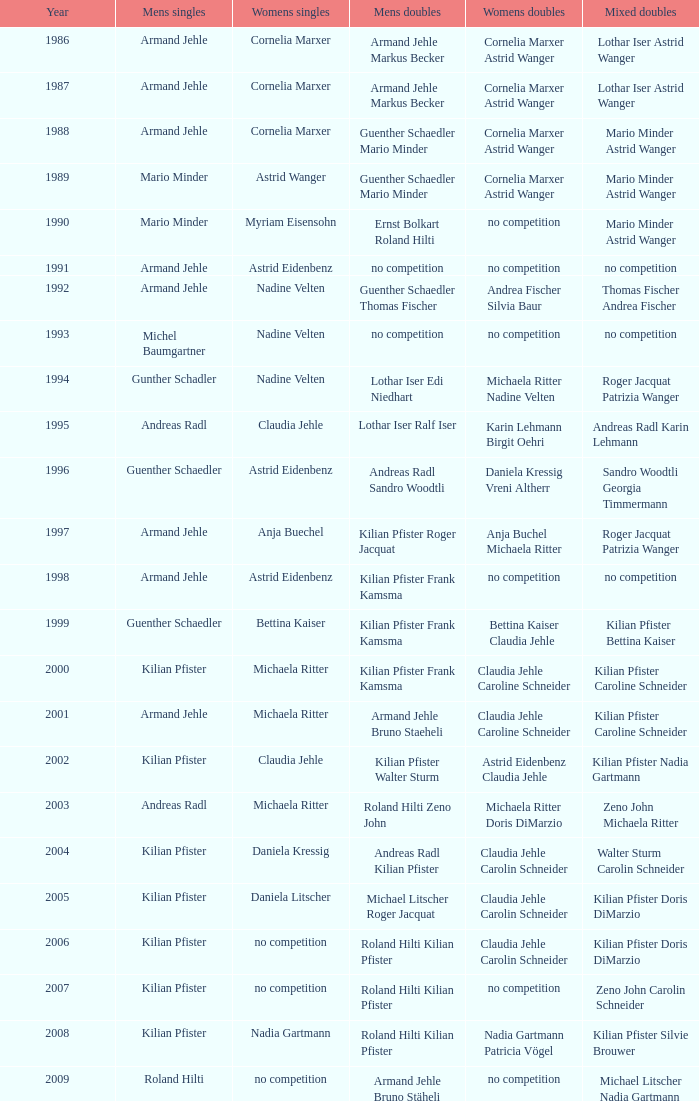Who secured the men's singles victory in 1987? Armand Jehle. 